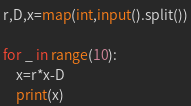<code> <loc_0><loc_0><loc_500><loc_500><_Python_>r,D,x=map(int,input().split())
 
for _ in range(10):
    x=r*x-D
    print(x)</code> 